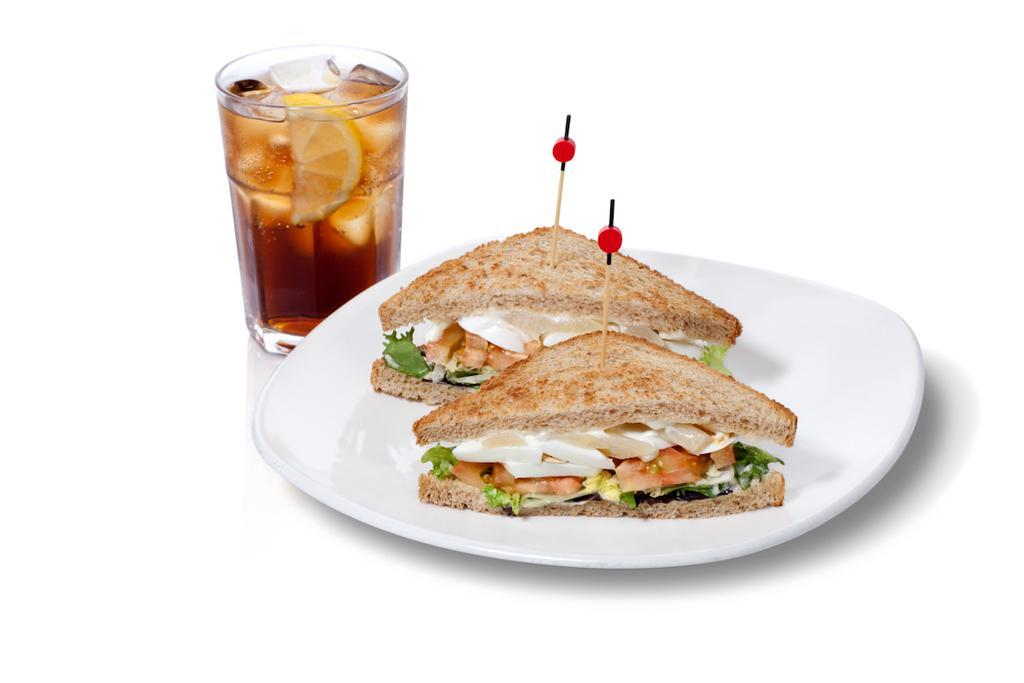Can you describe this image briefly? In this image I can see a white colored plate and on the plate I can see two sandwiches which are white, brown , cream, green , yellow and red in color. I can see a glass with liquid and lemon piece in it. I can see the white colored background. 